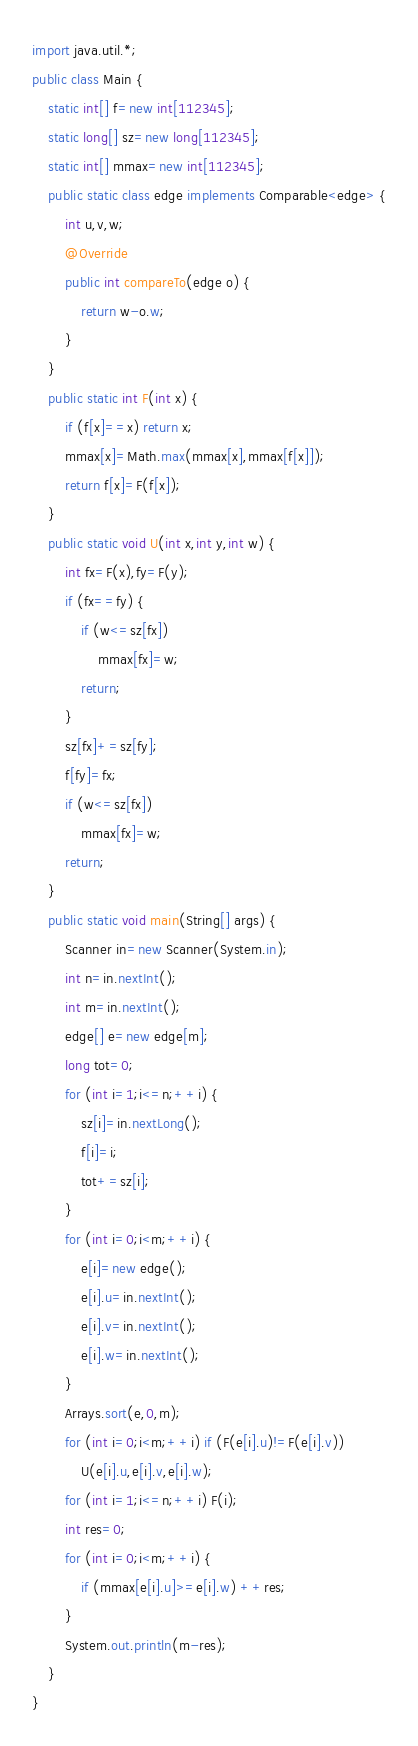<code> <loc_0><loc_0><loc_500><loc_500><_Java_>import java.util.*;
public class Main {
	static int[] f=new int[112345];
	static long[] sz=new long[112345];
	static int[] mmax=new int[112345];
	public static class edge implements Comparable<edge> {
		int u,v,w;
		@Override
		public int compareTo(edge o) {
			return w-o.w;
		}
	}
	public static int F(int x) {
		if (f[x]==x) return x;
		mmax[x]=Math.max(mmax[x],mmax[f[x]]);
		return f[x]=F(f[x]);
	}
	public static void U(int x,int y,int w) {
		int fx=F(x),fy=F(y);
		if (fx==fy) {
			if (w<=sz[fx])
				mmax[fx]=w;
			return;
		}
		sz[fx]+=sz[fy];
		f[fy]=fx;
		if (w<=sz[fx])
			mmax[fx]=w;
		return;
	}
	public static void main(String[] args) {
		Scanner in=new Scanner(System.in);
		int n=in.nextInt();
		int m=in.nextInt();
		edge[] e=new edge[m];
		long tot=0;
		for (int i=1;i<=n;++i) {
			sz[i]=in.nextLong();
			f[i]=i;
			tot+=sz[i];
		}
		for (int i=0;i<m;++i) {
			e[i]=new edge();
			e[i].u=in.nextInt();
			e[i].v=in.nextInt();
			e[i].w=in.nextInt();
		}
		Arrays.sort(e,0,m);
		for (int i=0;i<m;++i) if (F(e[i].u)!=F(e[i].v))
			U(e[i].u,e[i].v,e[i].w);
		for (int i=1;i<=n;++i) F(i);
		int res=0;
		for (int i=0;i<m;++i) {
			if (mmax[e[i].u]>=e[i].w) ++res;
		}
		System.out.println(m-res);
	}
}</code> 